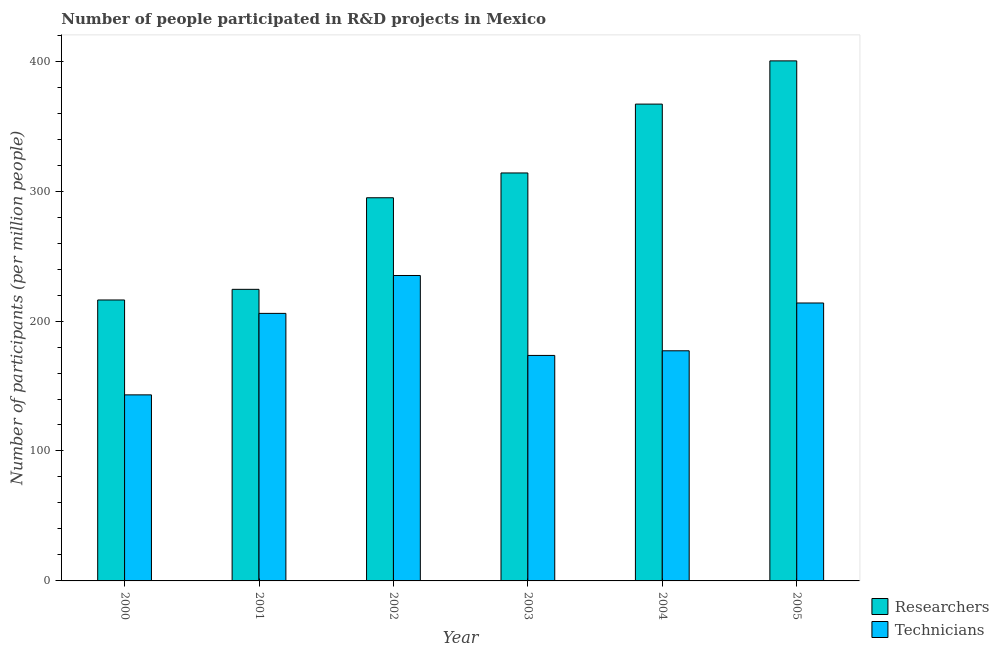How many groups of bars are there?
Ensure brevity in your answer.  6. Are the number of bars on each tick of the X-axis equal?
Give a very brief answer. Yes. In how many cases, is the number of bars for a given year not equal to the number of legend labels?
Your response must be concise. 0. What is the number of researchers in 2000?
Provide a succinct answer. 216.21. Across all years, what is the maximum number of technicians?
Provide a succinct answer. 235.05. Across all years, what is the minimum number of technicians?
Your answer should be very brief. 143.18. What is the total number of researchers in the graph?
Your response must be concise. 1816.57. What is the difference between the number of researchers in 2002 and that in 2004?
Give a very brief answer. -72.07. What is the difference between the number of researchers in 2003 and the number of technicians in 2004?
Your response must be concise. -52.99. What is the average number of technicians per year?
Offer a very short reply. 191.44. In the year 2003, what is the difference between the number of technicians and number of researchers?
Give a very brief answer. 0. In how many years, is the number of researchers greater than 260?
Your answer should be very brief. 4. What is the ratio of the number of researchers in 2003 to that in 2004?
Keep it short and to the point. 0.86. Is the difference between the number of technicians in 2000 and 2001 greater than the difference between the number of researchers in 2000 and 2001?
Provide a succinct answer. No. What is the difference between the highest and the second highest number of technicians?
Provide a short and direct response. 21.16. What is the difference between the highest and the lowest number of technicians?
Ensure brevity in your answer.  91.87. What does the 1st bar from the left in 2004 represents?
Your response must be concise. Researchers. What does the 1st bar from the right in 2004 represents?
Provide a succinct answer. Technicians. How many bars are there?
Offer a terse response. 12. Are all the bars in the graph horizontal?
Ensure brevity in your answer.  No. What is the difference between two consecutive major ticks on the Y-axis?
Make the answer very short. 100. Are the values on the major ticks of Y-axis written in scientific E-notation?
Your answer should be very brief. No. Does the graph contain any zero values?
Keep it short and to the point. No. Where does the legend appear in the graph?
Your response must be concise. Bottom right. How are the legend labels stacked?
Keep it short and to the point. Vertical. What is the title of the graph?
Ensure brevity in your answer.  Number of people participated in R&D projects in Mexico. Does "Commercial bank branches" appear as one of the legend labels in the graph?
Make the answer very short. No. What is the label or title of the X-axis?
Keep it short and to the point. Year. What is the label or title of the Y-axis?
Make the answer very short. Number of participants (per million people). What is the Number of participants (per million people) in Researchers in 2000?
Give a very brief answer. 216.21. What is the Number of participants (per million people) in Technicians in 2000?
Your answer should be compact. 143.18. What is the Number of participants (per million people) in Researchers in 2001?
Provide a succinct answer. 224.39. What is the Number of participants (per million people) in Technicians in 2001?
Keep it short and to the point. 205.89. What is the Number of participants (per million people) in Researchers in 2002?
Your answer should be compact. 294.87. What is the Number of participants (per million people) in Technicians in 2002?
Ensure brevity in your answer.  235.05. What is the Number of participants (per million people) in Researchers in 2003?
Offer a very short reply. 313.95. What is the Number of participants (per million people) of Technicians in 2003?
Give a very brief answer. 173.53. What is the Number of participants (per million people) in Researchers in 2004?
Make the answer very short. 366.94. What is the Number of participants (per million people) in Technicians in 2004?
Make the answer very short. 177.1. What is the Number of participants (per million people) of Researchers in 2005?
Offer a very short reply. 400.21. What is the Number of participants (per million people) in Technicians in 2005?
Keep it short and to the point. 213.89. Across all years, what is the maximum Number of participants (per million people) in Researchers?
Make the answer very short. 400.21. Across all years, what is the maximum Number of participants (per million people) in Technicians?
Offer a terse response. 235.05. Across all years, what is the minimum Number of participants (per million people) of Researchers?
Provide a short and direct response. 216.21. Across all years, what is the minimum Number of participants (per million people) in Technicians?
Provide a short and direct response. 143.18. What is the total Number of participants (per million people) in Researchers in the graph?
Make the answer very short. 1816.57. What is the total Number of participants (per million people) of Technicians in the graph?
Provide a succinct answer. 1148.63. What is the difference between the Number of participants (per million people) in Researchers in 2000 and that in 2001?
Give a very brief answer. -8.18. What is the difference between the Number of participants (per million people) in Technicians in 2000 and that in 2001?
Your response must be concise. -62.71. What is the difference between the Number of participants (per million people) in Researchers in 2000 and that in 2002?
Offer a terse response. -78.66. What is the difference between the Number of participants (per million people) of Technicians in 2000 and that in 2002?
Provide a succinct answer. -91.87. What is the difference between the Number of participants (per million people) of Researchers in 2000 and that in 2003?
Give a very brief answer. -97.75. What is the difference between the Number of participants (per million people) in Technicians in 2000 and that in 2003?
Make the answer very short. -30.35. What is the difference between the Number of participants (per million people) of Researchers in 2000 and that in 2004?
Offer a very short reply. -150.73. What is the difference between the Number of participants (per million people) in Technicians in 2000 and that in 2004?
Your response must be concise. -33.92. What is the difference between the Number of participants (per million people) of Researchers in 2000 and that in 2005?
Ensure brevity in your answer.  -184. What is the difference between the Number of participants (per million people) in Technicians in 2000 and that in 2005?
Your answer should be compact. -70.71. What is the difference between the Number of participants (per million people) of Researchers in 2001 and that in 2002?
Make the answer very short. -70.48. What is the difference between the Number of participants (per million people) in Technicians in 2001 and that in 2002?
Give a very brief answer. -29.16. What is the difference between the Number of participants (per million people) of Researchers in 2001 and that in 2003?
Make the answer very short. -89.56. What is the difference between the Number of participants (per million people) in Technicians in 2001 and that in 2003?
Offer a terse response. 32.36. What is the difference between the Number of participants (per million people) in Researchers in 2001 and that in 2004?
Your response must be concise. -142.55. What is the difference between the Number of participants (per million people) of Technicians in 2001 and that in 2004?
Provide a succinct answer. 28.79. What is the difference between the Number of participants (per million people) in Researchers in 2001 and that in 2005?
Your answer should be very brief. -175.82. What is the difference between the Number of participants (per million people) in Technicians in 2001 and that in 2005?
Provide a short and direct response. -8. What is the difference between the Number of participants (per million people) of Researchers in 2002 and that in 2003?
Offer a very short reply. -19.08. What is the difference between the Number of participants (per million people) of Technicians in 2002 and that in 2003?
Offer a terse response. 61.52. What is the difference between the Number of participants (per million people) of Researchers in 2002 and that in 2004?
Your answer should be compact. -72.07. What is the difference between the Number of participants (per million people) of Technicians in 2002 and that in 2004?
Your answer should be compact. 57.95. What is the difference between the Number of participants (per million people) in Researchers in 2002 and that in 2005?
Your response must be concise. -105.34. What is the difference between the Number of participants (per million people) of Technicians in 2002 and that in 2005?
Provide a short and direct response. 21.16. What is the difference between the Number of participants (per million people) of Researchers in 2003 and that in 2004?
Your answer should be compact. -52.99. What is the difference between the Number of participants (per million people) of Technicians in 2003 and that in 2004?
Keep it short and to the point. -3.57. What is the difference between the Number of participants (per million people) of Researchers in 2003 and that in 2005?
Give a very brief answer. -86.25. What is the difference between the Number of participants (per million people) in Technicians in 2003 and that in 2005?
Make the answer very short. -40.36. What is the difference between the Number of participants (per million people) in Researchers in 2004 and that in 2005?
Provide a succinct answer. -33.27. What is the difference between the Number of participants (per million people) of Technicians in 2004 and that in 2005?
Ensure brevity in your answer.  -36.79. What is the difference between the Number of participants (per million people) in Researchers in 2000 and the Number of participants (per million people) in Technicians in 2001?
Make the answer very short. 10.32. What is the difference between the Number of participants (per million people) in Researchers in 2000 and the Number of participants (per million people) in Technicians in 2002?
Your answer should be compact. -18.84. What is the difference between the Number of participants (per million people) in Researchers in 2000 and the Number of participants (per million people) in Technicians in 2003?
Give a very brief answer. 42.68. What is the difference between the Number of participants (per million people) of Researchers in 2000 and the Number of participants (per million people) of Technicians in 2004?
Give a very brief answer. 39.11. What is the difference between the Number of participants (per million people) of Researchers in 2000 and the Number of participants (per million people) of Technicians in 2005?
Provide a short and direct response. 2.32. What is the difference between the Number of participants (per million people) of Researchers in 2001 and the Number of participants (per million people) of Technicians in 2002?
Offer a terse response. -10.66. What is the difference between the Number of participants (per million people) in Researchers in 2001 and the Number of participants (per million people) in Technicians in 2003?
Your answer should be very brief. 50.86. What is the difference between the Number of participants (per million people) of Researchers in 2001 and the Number of participants (per million people) of Technicians in 2004?
Offer a terse response. 47.29. What is the difference between the Number of participants (per million people) in Researchers in 2001 and the Number of participants (per million people) in Technicians in 2005?
Make the answer very short. 10.5. What is the difference between the Number of participants (per million people) in Researchers in 2002 and the Number of participants (per million people) in Technicians in 2003?
Keep it short and to the point. 121.34. What is the difference between the Number of participants (per million people) in Researchers in 2002 and the Number of participants (per million people) in Technicians in 2004?
Your response must be concise. 117.77. What is the difference between the Number of participants (per million people) in Researchers in 2002 and the Number of participants (per million people) in Technicians in 2005?
Your answer should be compact. 80.99. What is the difference between the Number of participants (per million people) of Researchers in 2003 and the Number of participants (per million people) of Technicians in 2004?
Give a very brief answer. 136.85. What is the difference between the Number of participants (per million people) of Researchers in 2003 and the Number of participants (per million people) of Technicians in 2005?
Offer a very short reply. 100.07. What is the difference between the Number of participants (per million people) in Researchers in 2004 and the Number of participants (per million people) in Technicians in 2005?
Your answer should be compact. 153.05. What is the average Number of participants (per million people) in Researchers per year?
Keep it short and to the point. 302.76. What is the average Number of participants (per million people) of Technicians per year?
Make the answer very short. 191.44. In the year 2000, what is the difference between the Number of participants (per million people) in Researchers and Number of participants (per million people) in Technicians?
Provide a short and direct response. 73.03. In the year 2001, what is the difference between the Number of participants (per million people) in Researchers and Number of participants (per million people) in Technicians?
Provide a succinct answer. 18.5. In the year 2002, what is the difference between the Number of participants (per million people) in Researchers and Number of participants (per million people) in Technicians?
Your response must be concise. 59.82. In the year 2003, what is the difference between the Number of participants (per million people) of Researchers and Number of participants (per million people) of Technicians?
Provide a succinct answer. 140.43. In the year 2004, what is the difference between the Number of participants (per million people) of Researchers and Number of participants (per million people) of Technicians?
Your answer should be compact. 189.84. In the year 2005, what is the difference between the Number of participants (per million people) of Researchers and Number of participants (per million people) of Technicians?
Offer a terse response. 186.32. What is the ratio of the Number of participants (per million people) of Researchers in 2000 to that in 2001?
Ensure brevity in your answer.  0.96. What is the ratio of the Number of participants (per million people) in Technicians in 2000 to that in 2001?
Your answer should be compact. 0.7. What is the ratio of the Number of participants (per million people) in Researchers in 2000 to that in 2002?
Offer a very short reply. 0.73. What is the ratio of the Number of participants (per million people) in Technicians in 2000 to that in 2002?
Offer a terse response. 0.61. What is the ratio of the Number of participants (per million people) in Researchers in 2000 to that in 2003?
Provide a short and direct response. 0.69. What is the ratio of the Number of participants (per million people) of Technicians in 2000 to that in 2003?
Your response must be concise. 0.83. What is the ratio of the Number of participants (per million people) in Researchers in 2000 to that in 2004?
Make the answer very short. 0.59. What is the ratio of the Number of participants (per million people) of Technicians in 2000 to that in 2004?
Your answer should be compact. 0.81. What is the ratio of the Number of participants (per million people) of Researchers in 2000 to that in 2005?
Ensure brevity in your answer.  0.54. What is the ratio of the Number of participants (per million people) in Technicians in 2000 to that in 2005?
Provide a short and direct response. 0.67. What is the ratio of the Number of participants (per million people) of Researchers in 2001 to that in 2002?
Give a very brief answer. 0.76. What is the ratio of the Number of participants (per million people) in Technicians in 2001 to that in 2002?
Give a very brief answer. 0.88. What is the ratio of the Number of participants (per million people) of Researchers in 2001 to that in 2003?
Provide a succinct answer. 0.71. What is the ratio of the Number of participants (per million people) of Technicians in 2001 to that in 2003?
Offer a very short reply. 1.19. What is the ratio of the Number of participants (per million people) of Researchers in 2001 to that in 2004?
Offer a very short reply. 0.61. What is the ratio of the Number of participants (per million people) of Technicians in 2001 to that in 2004?
Ensure brevity in your answer.  1.16. What is the ratio of the Number of participants (per million people) in Researchers in 2001 to that in 2005?
Your response must be concise. 0.56. What is the ratio of the Number of participants (per million people) in Technicians in 2001 to that in 2005?
Your answer should be very brief. 0.96. What is the ratio of the Number of participants (per million people) of Researchers in 2002 to that in 2003?
Your answer should be very brief. 0.94. What is the ratio of the Number of participants (per million people) of Technicians in 2002 to that in 2003?
Provide a succinct answer. 1.35. What is the ratio of the Number of participants (per million people) in Researchers in 2002 to that in 2004?
Give a very brief answer. 0.8. What is the ratio of the Number of participants (per million people) in Technicians in 2002 to that in 2004?
Provide a succinct answer. 1.33. What is the ratio of the Number of participants (per million people) in Researchers in 2002 to that in 2005?
Offer a terse response. 0.74. What is the ratio of the Number of participants (per million people) of Technicians in 2002 to that in 2005?
Provide a succinct answer. 1.1. What is the ratio of the Number of participants (per million people) of Researchers in 2003 to that in 2004?
Make the answer very short. 0.86. What is the ratio of the Number of participants (per million people) in Technicians in 2003 to that in 2004?
Offer a very short reply. 0.98. What is the ratio of the Number of participants (per million people) of Researchers in 2003 to that in 2005?
Provide a short and direct response. 0.78. What is the ratio of the Number of participants (per million people) in Technicians in 2003 to that in 2005?
Offer a terse response. 0.81. What is the ratio of the Number of participants (per million people) of Researchers in 2004 to that in 2005?
Your answer should be very brief. 0.92. What is the ratio of the Number of participants (per million people) of Technicians in 2004 to that in 2005?
Provide a short and direct response. 0.83. What is the difference between the highest and the second highest Number of participants (per million people) of Researchers?
Make the answer very short. 33.27. What is the difference between the highest and the second highest Number of participants (per million people) of Technicians?
Offer a terse response. 21.16. What is the difference between the highest and the lowest Number of participants (per million people) in Researchers?
Keep it short and to the point. 184. What is the difference between the highest and the lowest Number of participants (per million people) of Technicians?
Make the answer very short. 91.87. 